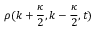Convert formula to latex. <formula><loc_0><loc_0><loc_500><loc_500>\rho ( k + \frac { \kappa } { 2 } , k - \frac { \kappa } { 2 } , t )</formula> 